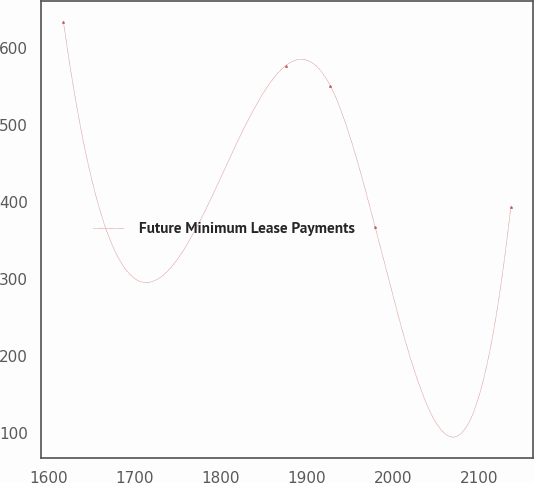Convert chart to OTSL. <chart><loc_0><loc_0><loc_500><loc_500><line_chart><ecel><fcel>Future Minimum Lease Payments<nl><fcel>1616.92<fcel>634.61<nl><fcel>1875.24<fcel>577.45<nl><fcel>1927.23<fcel>550.74<nl><fcel>1979.22<fcel>367.47<nl><fcel>2136.78<fcel>394.18<nl></chart> 